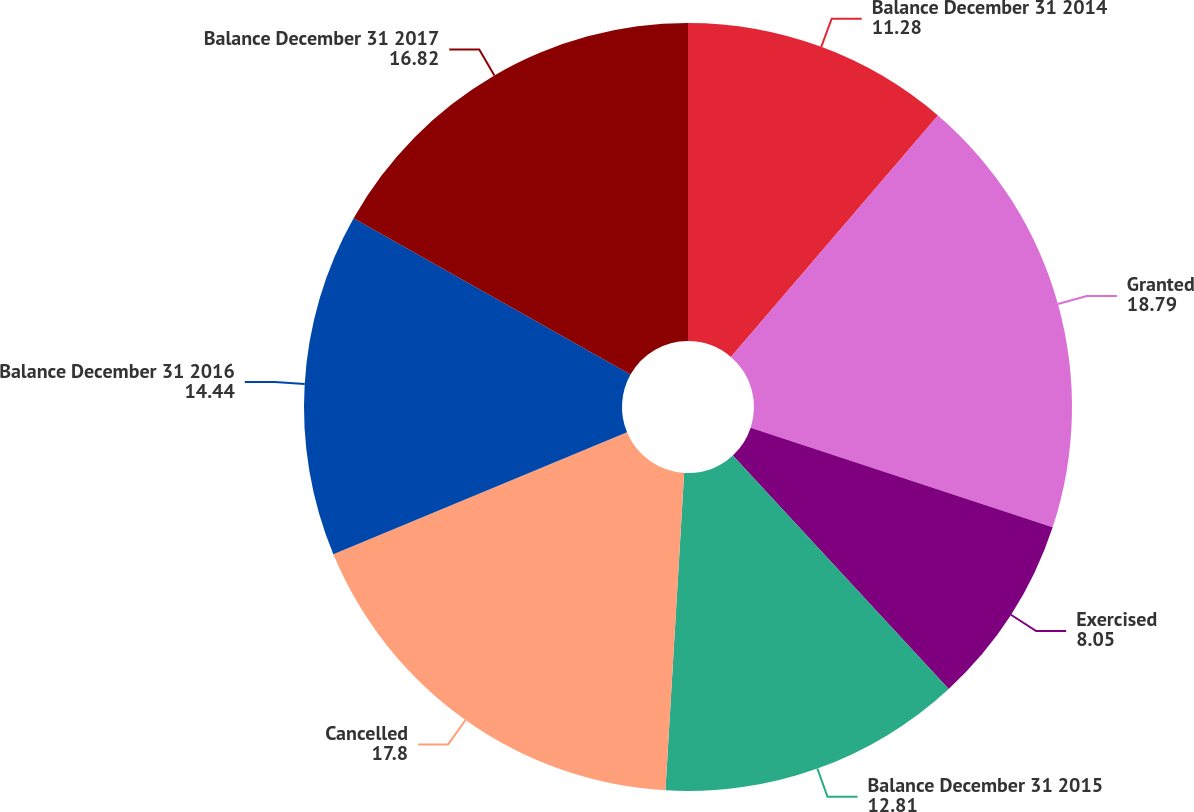Convert chart to OTSL. <chart><loc_0><loc_0><loc_500><loc_500><pie_chart><fcel>Balance December 31 2014<fcel>Granted<fcel>Exercised<fcel>Balance December 31 2015<fcel>Cancelled<fcel>Balance December 31 2016<fcel>Balance December 31 2017<nl><fcel>11.28%<fcel>18.79%<fcel>8.05%<fcel>12.81%<fcel>17.8%<fcel>14.44%<fcel>16.82%<nl></chart> 